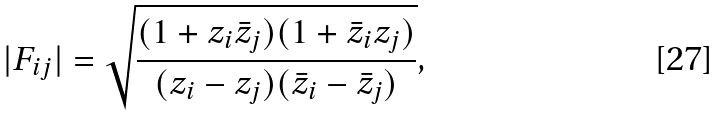<formula> <loc_0><loc_0><loc_500><loc_500>| F _ { i j } | = \sqrt { \frac { ( 1 + z _ { i } \bar { z } _ { j } ) ( 1 + \bar { z } _ { i } z _ { j } ) } { ( z _ { i } - z _ { j } ) ( \bar { z } _ { i } - \bar { z } _ { j } ) } } ,</formula> 